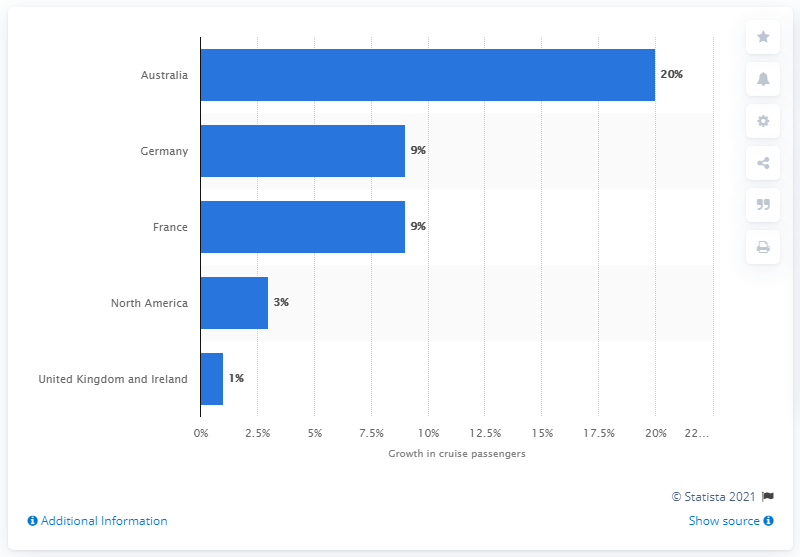Compared to Australia, how do the passenger growth percentages of North America and the UK/Ireland reflect in the cruise industry? North America's growth in cruise passengers is significantly lower than Australia's at 3%, while the United Kingdom and Ireland have the smallest increase at 1%, as illustrated by the bar graph. 